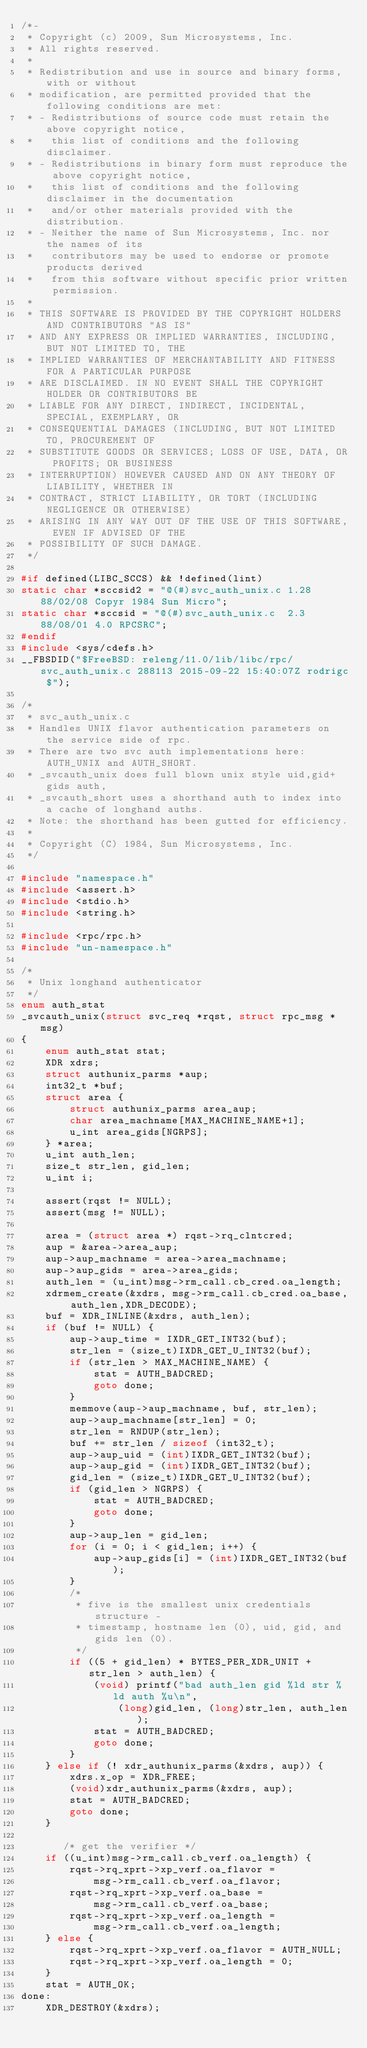Convert code to text. <code><loc_0><loc_0><loc_500><loc_500><_C_>/*-
 * Copyright (c) 2009, Sun Microsystems, Inc.
 * All rights reserved.
 *
 * Redistribution and use in source and binary forms, with or without 
 * modification, are permitted provided that the following conditions are met:
 * - Redistributions of source code must retain the above copyright notice, 
 *   this list of conditions and the following disclaimer.
 * - Redistributions in binary form must reproduce the above copyright notice, 
 *   this list of conditions and the following disclaimer in the documentation 
 *   and/or other materials provided with the distribution.
 * - Neither the name of Sun Microsystems, Inc. nor the names of its 
 *   contributors may be used to endorse or promote products derived 
 *   from this software without specific prior written permission.
 * 
 * THIS SOFTWARE IS PROVIDED BY THE COPYRIGHT HOLDERS AND CONTRIBUTORS "AS IS" 
 * AND ANY EXPRESS OR IMPLIED WARRANTIES, INCLUDING, BUT NOT LIMITED TO, THE 
 * IMPLIED WARRANTIES OF MERCHANTABILITY AND FITNESS FOR A PARTICULAR PURPOSE 
 * ARE DISCLAIMED. IN NO EVENT SHALL THE COPYRIGHT HOLDER OR CONTRIBUTORS BE 
 * LIABLE FOR ANY DIRECT, INDIRECT, INCIDENTAL, SPECIAL, EXEMPLARY, OR 
 * CONSEQUENTIAL DAMAGES (INCLUDING, BUT NOT LIMITED TO, PROCUREMENT OF 
 * SUBSTITUTE GOODS OR SERVICES; LOSS OF USE, DATA, OR PROFITS; OR BUSINESS 
 * INTERRUPTION) HOWEVER CAUSED AND ON ANY THEORY OF LIABILITY, WHETHER IN 
 * CONTRACT, STRICT LIABILITY, OR TORT (INCLUDING NEGLIGENCE OR OTHERWISE) 
 * ARISING IN ANY WAY OUT OF THE USE OF THIS SOFTWARE, EVEN IF ADVISED OF THE 
 * POSSIBILITY OF SUCH DAMAGE.
 */

#if defined(LIBC_SCCS) && !defined(lint)
static char *sccsid2 = "@(#)svc_auth_unix.c 1.28 88/02/08 Copyr 1984 Sun Micro";
static char *sccsid = "@(#)svc_auth_unix.c	2.3 88/08/01 4.0 RPCSRC";
#endif
#include <sys/cdefs.h>
__FBSDID("$FreeBSD: releng/11.0/lib/libc/rpc/svc_auth_unix.c 288113 2015-09-22 15:40:07Z rodrigc $");

/*
 * svc_auth_unix.c
 * Handles UNIX flavor authentication parameters on the service side of rpc.
 * There are two svc auth implementations here: AUTH_UNIX and AUTH_SHORT.
 * _svcauth_unix does full blown unix style uid,gid+gids auth,
 * _svcauth_short uses a shorthand auth to index into a cache of longhand auths.
 * Note: the shorthand has been gutted for efficiency.
 *
 * Copyright (C) 1984, Sun Microsystems, Inc.
 */

#include "namespace.h"
#include <assert.h>
#include <stdio.h>
#include <string.h>

#include <rpc/rpc.h>
#include "un-namespace.h"

/*
 * Unix longhand authenticator
 */
enum auth_stat
_svcauth_unix(struct svc_req *rqst, struct rpc_msg *msg)
{
	enum auth_stat stat;
	XDR xdrs;
	struct authunix_parms *aup;
	int32_t *buf;
	struct area {
		struct authunix_parms area_aup;
		char area_machname[MAX_MACHINE_NAME+1];
		u_int area_gids[NGRPS];
	} *area;
	u_int auth_len;
	size_t str_len, gid_len;
	u_int i;

	assert(rqst != NULL);
	assert(msg != NULL);

	area = (struct area *) rqst->rq_clntcred;
	aup = &area->area_aup;
	aup->aup_machname = area->area_machname;
	aup->aup_gids = area->area_gids;
	auth_len = (u_int)msg->rm_call.cb_cred.oa_length;
	xdrmem_create(&xdrs, msg->rm_call.cb_cred.oa_base, auth_len,XDR_DECODE);
	buf = XDR_INLINE(&xdrs, auth_len);
	if (buf != NULL) {
		aup->aup_time = IXDR_GET_INT32(buf);
		str_len = (size_t)IXDR_GET_U_INT32(buf);
		if (str_len > MAX_MACHINE_NAME) {
			stat = AUTH_BADCRED;
			goto done;
		}
		memmove(aup->aup_machname, buf, str_len);
		aup->aup_machname[str_len] = 0;
		str_len = RNDUP(str_len);
		buf += str_len / sizeof (int32_t);
		aup->aup_uid = (int)IXDR_GET_INT32(buf);
		aup->aup_gid = (int)IXDR_GET_INT32(buf);
		gid_len = (size_t)IXDR_GET_U_INT32(buf);
		if (gid_len > NGRPS) {
			stat = AUTH_BADCRED;
			goto done;
		}
		aup->aup_len = gid_len;
		for (i = 0; i < gid_len; i++) {
			aup->aup_gids[i] = (int)IXDR_GET_INT32(buf);
		}
		/*
		 * five is the smallest unix credentials structure -
		 * timestamp, hostname len (0), uid, gid, and gids len (0).
		 */
		if ((5 + gid_len) * BYTES_PER_XDR_UNIT + str_len > auth_len) {
			(void) printf("bad auth_len gid %ld str %ld auth %u\n",
			    (long)gid_len, (long)str_len, auth_len);
			stat = AUTH_BADCRED;
			goto done;
		}
	} else if (! xdr_authunix_parms(&xdrs, aup)) {
		xdrs.x_op = XDR_FREE;
		(void)xdr_authunix_parms(&xdrs, aup);
		stat = AUTH_BADCRED;
		goto done;
	}

       /* get the verifier */
	if ((u_int)msg->rm_call.cb_verf.oa_length) {
		rqst->rq_xprt->xp_verf.oa_flavor =
			msg->rm_call.cb_verf.oa_flavor;
		rqst->rq_xprt->xp_verf.oa_base =
			msg->rm_call.cb_verf.oa_base;
		rqst->rq_xprt->xp_verf.oa_length =
			msg->rm_call.cb_verf.oa_length;
	} else {
		rqst->rq_xprt->xp_verf.oa_flavor = AUTH_NULL;
		rqst->rq_xprt->xp_verf.oa_length = 0;
	}
	stat = AUTH_OK;
done:
	XDR_DESTROY(&xdrs);</code> 